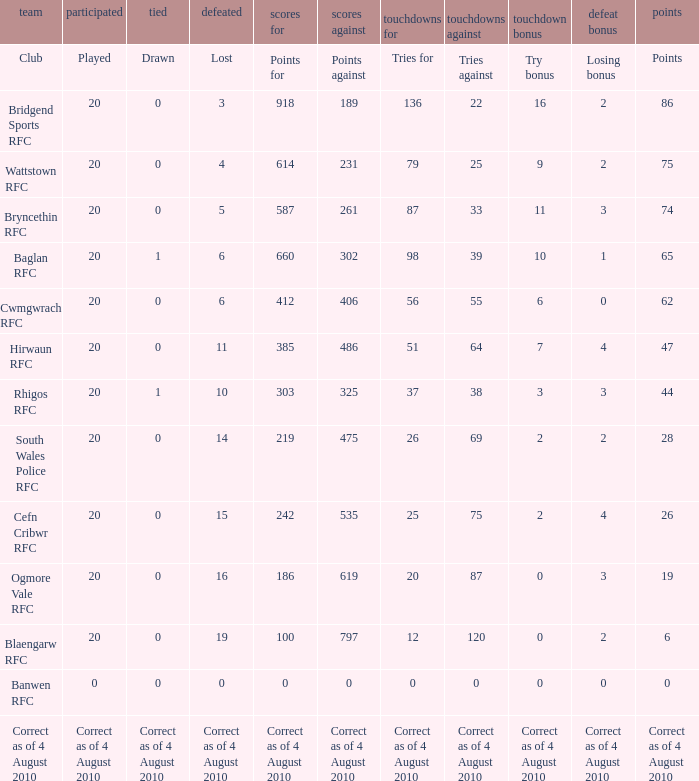What is lost when the points against is 231? 4.0. 